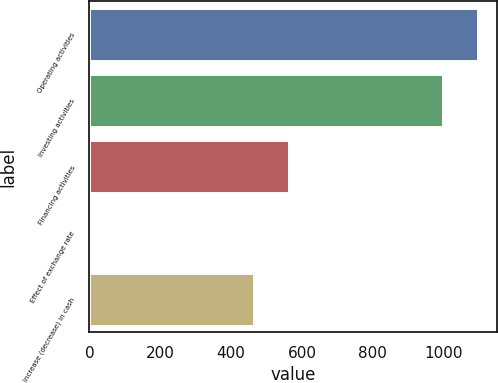Convert chart. <chart><loc_0><loc_0><loc_500><loc_500><bar_chart><fcel>Operating activities<fcel>Investing activities<fcel>Financing activities<fcel>Effect of exchange rate<fcel>Increase (decrease) in cash<nl><fcel>1096.7<fcel>997<fcel>564.7<fcel>1<fcel>465<nl></chart> 